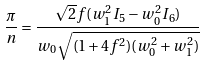Convert formula to latex. <formula><loc_0><loc_0><loc_500><loc_500>\frac { \pi } { n } = \frac { \sqrt { 2 } f ( w _ { 1 } ^ { 2 } I _ { 5 } - w _ { 0 } ^ { 2 } I _ { 6 } ) } { w _ { 0 } \sqrt { ( 1 + 4 f ^ { 2 } ) ( w _ { 0 } ^ { 2 } + w _ { 1 } ^ { 2 } ) } }</formula> 